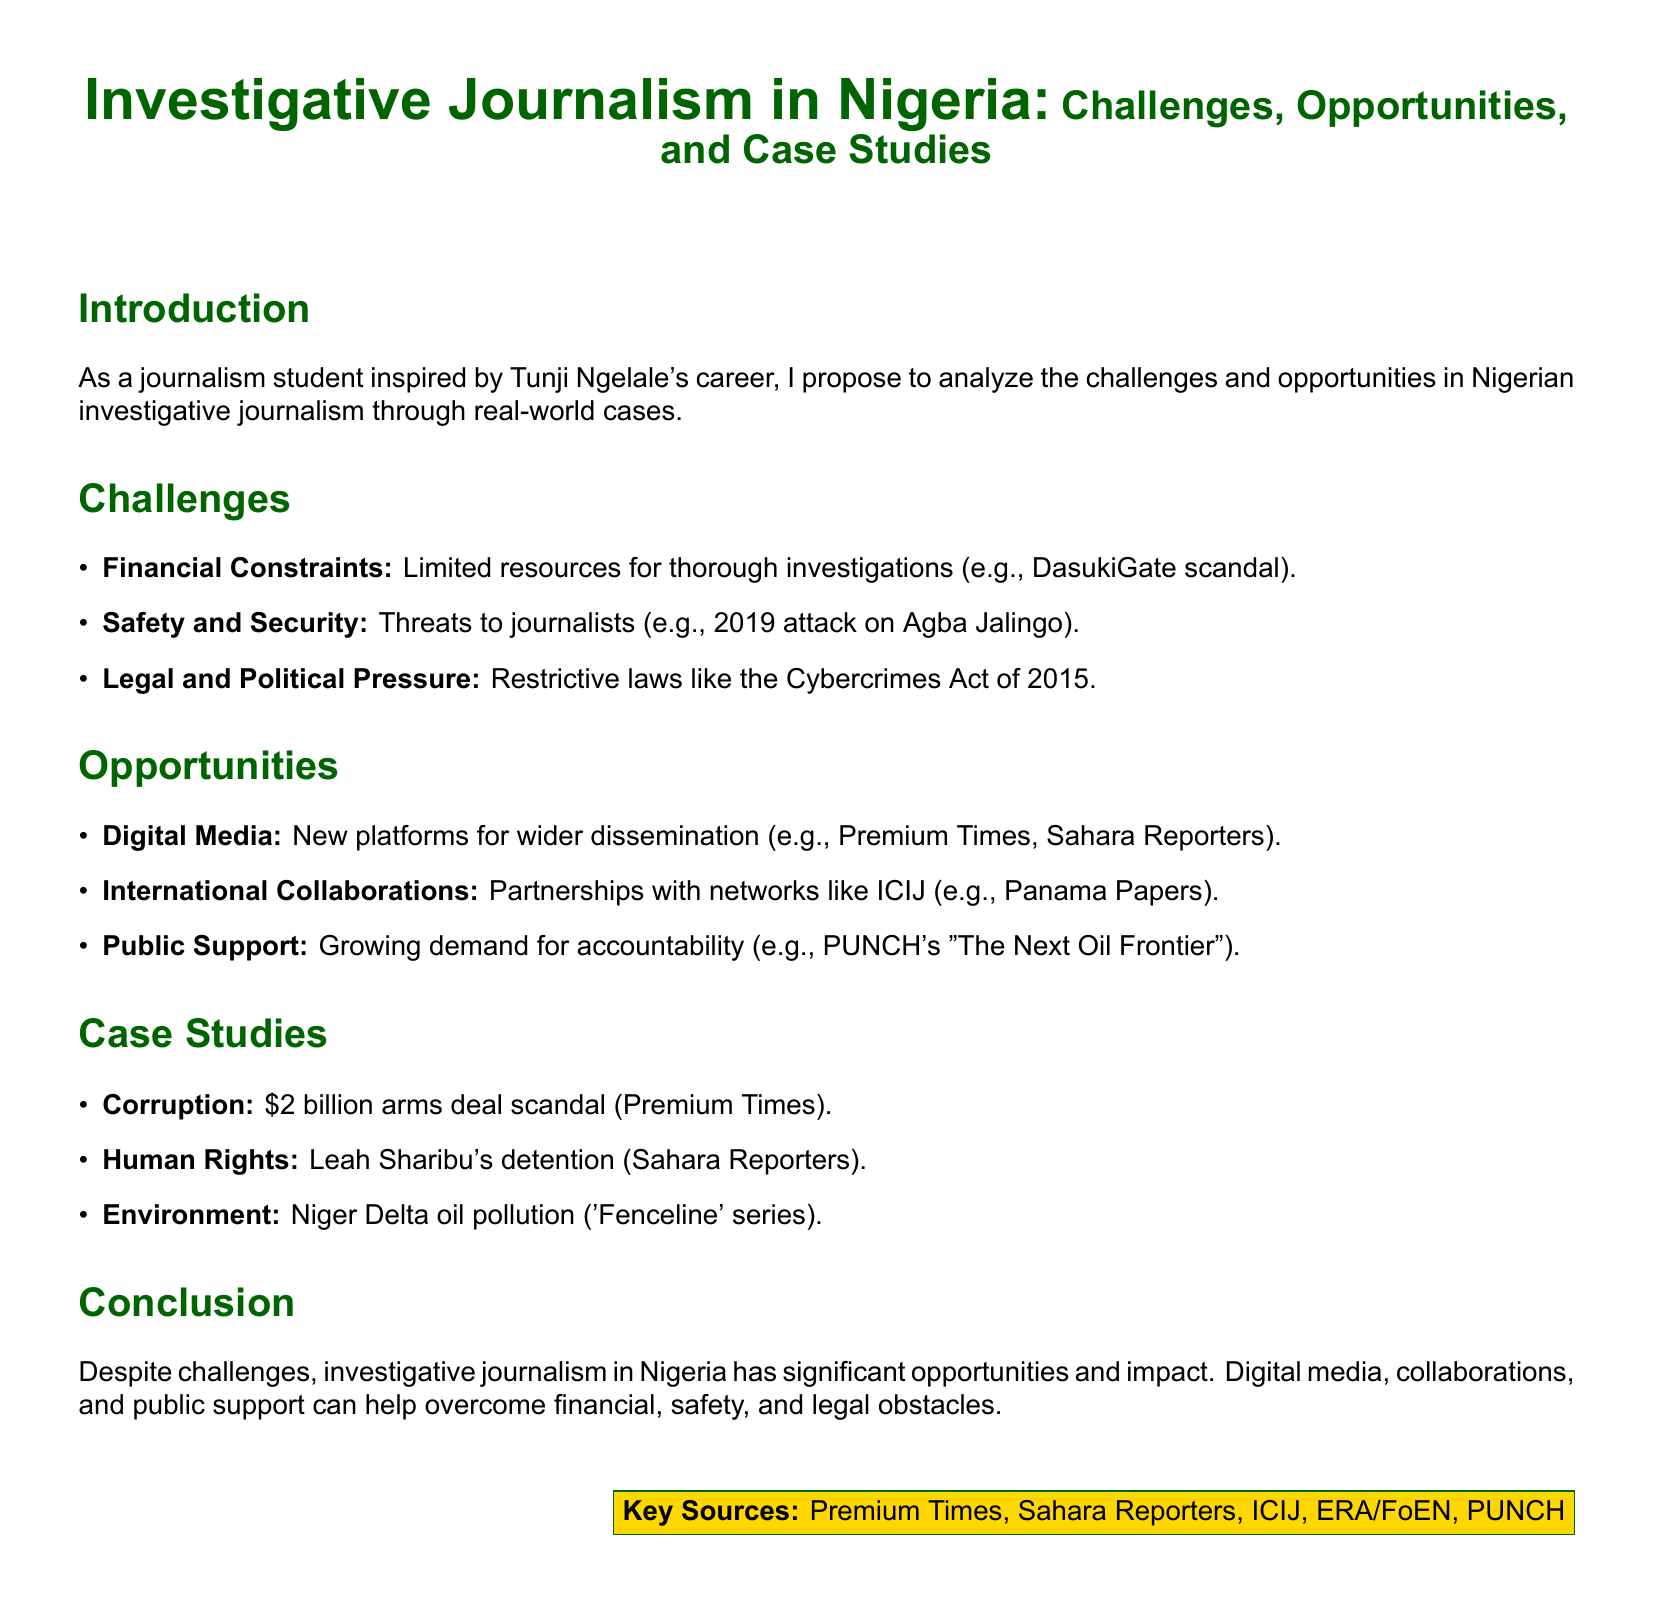What is the main focus of the proposal? The proposal aims to analyze challenges and opportunities in Nigerian investigative journalism.
Answer: Challenges and opportunities in Nigerian investigative journalism What incident is cited as an example of financial constraints? The document references DasukiGate scandal as an example of financial constraints.
Answer: DasukiGate scandal Which journalist was attacked in 2019? The document mentions Agba Jalingo as the journalist who was attacked in 2019.
Answer: Agba Jalingo What is one of the opportunities mentioned in the proposal? The proposal lists digital media as one opportunity for investigative journalism.
Answer: Digital media What scandal involving arms deals is mentioned in the case studies? The proposal highlights a $2 billion arms deal scandal as a notable case study.
Answer: $2 billion arms deal scandal Which organization's partnerships are mentioned as beneficial for investigative journalism? The document mentions collaborations with the International Consortium of Investigative Journalists (ICIJ).
Answer: ICIJ What is a significant public demand referenced in the opportunities section? The proposal indicates a growing demand for accountability as a significant public demand.
Answer: Accountability What environmental issue is discussed in the case studies? The document refers to Niger Delta oil pollution as an environmental issue in the case studies.
Answer: Niger Delta oil pollution What is the title of the proposal? The title of the proposal is "Investigative Journalism in Nigeria: Challenges, Opportunities, and Case Studies."
Answer: Investigative Journalism in Nigeria: Challenges, Opportunities, and Case Studies 